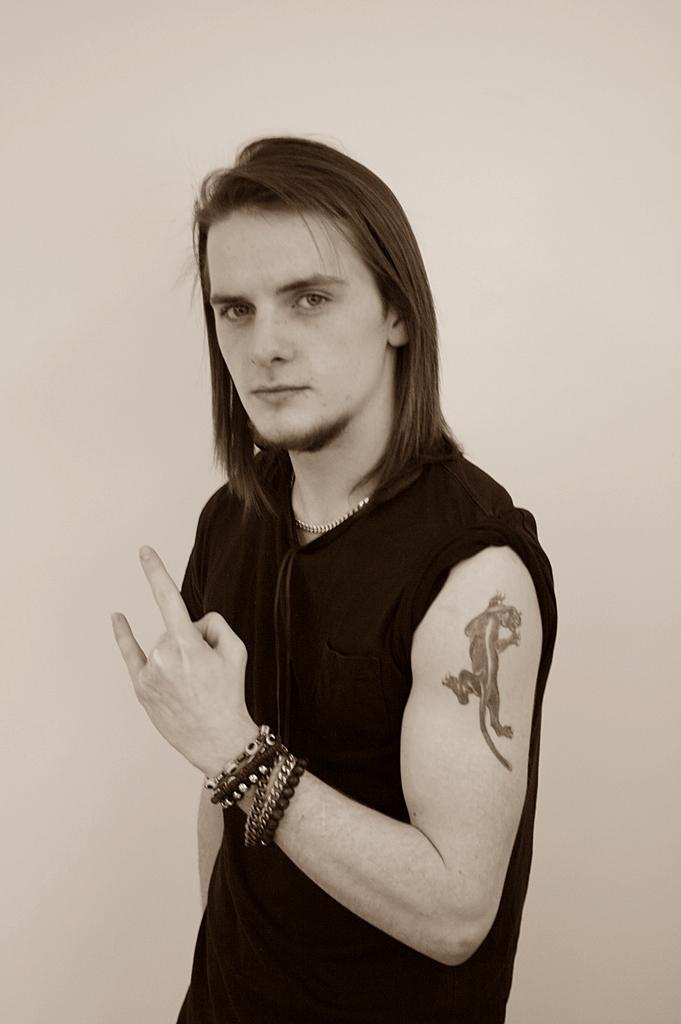Who or what is present in the image? There is a person in the image. What can be seen in the background of the image? There is a wall in the background of the image. How many chairs are visible in the image? There are no chairs present in the image. What type of arch can be seen in the image? There is no arch present in the image. 